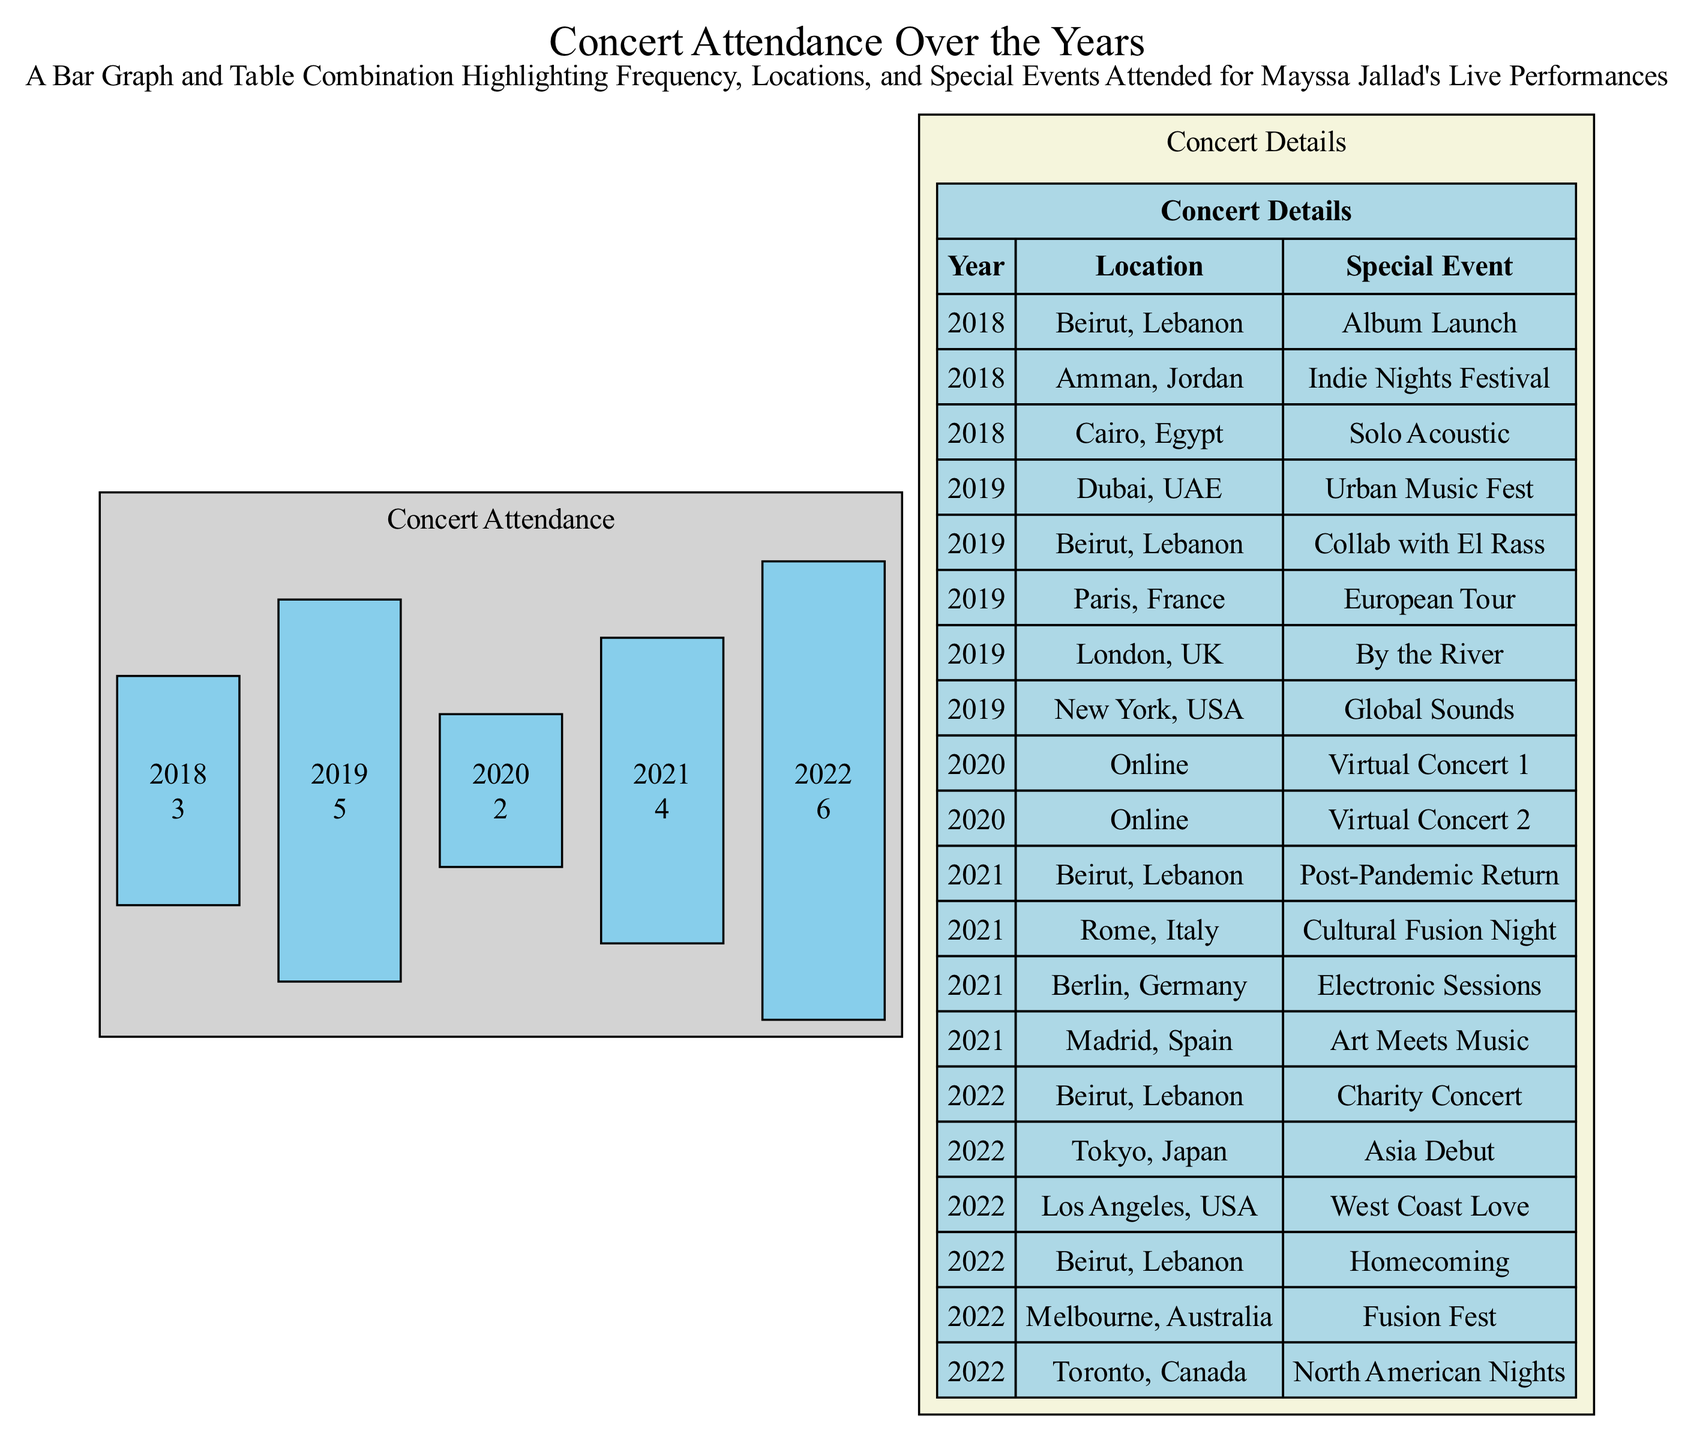What year did Mayssa Jallad attend the most concerts? The bar graph shows the number of concerts attended each year. The year with the highest value is 2022, where she attended 6 concerts.
Answer: 2022 How many concerts did Mayssa Jallad attend in 2019? Referring to the bar graph, in 2019 the value for concerts attended is 5.
Answer: 5 Which location hosted a concert as part of an album launch in 2018? Looking at the table, the concert for the album launch took place in Beirut, Lebanon in 2018.
Answer: Beirut, Lebanon How many special events did Mayssa Jallad perform in 2021? Checking the table for 2021, there are 4 listed special events: Post-Pandemic Return, Cultural Fusion Night, Electronic Sessions, and Art Meets Music.
Answer: 4 What was the special event for Mayssa Jallad's concert in Tokyo, Japan? The table shows that the special event for the concert in Tokyo in 2022 was the Asia Debut.
Answer: Asia Debut Which year experienced a decrease in concert attendance compared to the previous year? Examining the bar graph, 2020 shows a decrease to 2 concerts from 5 in 2019.
Answer: 2020 Which location had the most events listed in the data? By reviewing the table, Beirut, Lebanon appears multiple times, specifically in 2018, 2021, and 2022, totaling 4 events.
Answer: Beirut, Lebanon What type of event was held in Los Angeles, USA, in 2022? According to the table, Mayssa Jallad performed at a West Coast Love event in Los Angeles in 2022.
Answer: West Coast Love In what year did Mayssa Jallad perform at a virtual concert? The table indicates that in 2020, both concerts listed were virtual events.
Answer: 2020 